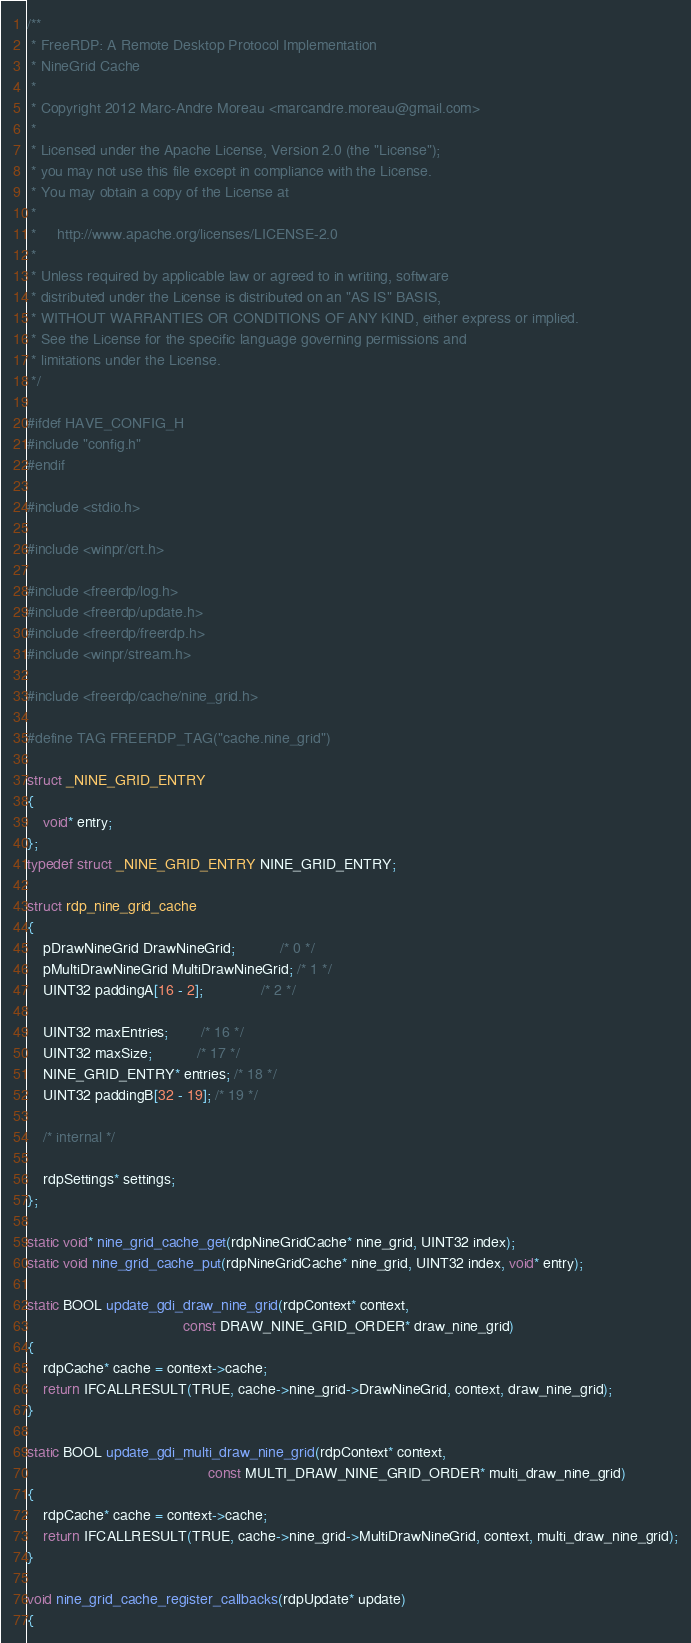Convert code to text. <code><loc_0><loc_0><loc_500><loc_500><_C_>/**
 * FreeRDP: A Remote Desktop Protocol Implementation
 * NineGrid Cache
 *
 * Copyright 2012 Marc-Andre Moreau <marcandre.moreau@gmail.com>
 *
 * Licensed under the Apache License, Version 2.0 (the "License");
 * you may not use this file except in compliance with the License.
 * You may obtain a copy of the License at
 *
 *     http://www.apache.org/licenses/LICENSE-2.0
 *
 * Unless required by applicable law or agreed to in writing, software
 * distributed under the License is distributed on an "AS IS" BASIS,
 * WITHOUT WARRANTIES OR CONDITIONS OF ANY KIND, either express or implied.
 * See the License for the specific language governing permissions and
 * limitations under the License.
 */

#ifdef HAVE_CONFIG_H
#include "config.h"
#endif

#include <stdio.h>

#include <winpr/crt.h>

#include <freerdp/log.h>
#include <freerdp/update.h>
#include <freerdp/freerdp.h>
#include <winpr/stream.h>

#include <freerdp/cache/nine_grid.h>

#define TAG FREERDP_TAG("cache.nine_grid")

struct _NINE_GRID_ENTRY
{
	void* entry;
};
typedef struct _NINE_GRID_ENTRY NINE_GRID_ENTRY;

struct rdp_nine_grid_cache
{
	pDrawNineGrid DrawNineGrid;           /* 0 */
	pMultiDrawNineGrid MultiDrawNineGrid; /* 1 */
	UINT32 paddingA[16 - 2];              /* 2 */

	UINT32 maxEntries;        /* 16 */
	UINT32 maxSize;           /* 17 */
	NINE_GRID_ENTRY* entries; /* 18 */
	UINT32 paddingB[32 - 19]; /* 19 */

	/* internal */

	rdpSettings* settings;
};

static void* nine_grid_cache_get(rdpNineGridCache* nine_grid, UINT32 index);
static void nine_grid_cache_put(rdpNineGridCache* nine_grid, UINT32 index, void* entry);

static BOOL update_gdi_draw_nine_grid(rdpContext* context,
                                      const DRAW_NINE_GRID_ORDER* draw_nine_grid)
{
	rdpCache* cache = context->cache;
	return IFCALLRESULT(TRUE, cache->nine_grid->DrawNineGrid, context, draw_nine_grid);
}

static BOOL update_gdi_multi_draw_nine_grid(rdpContext* context,
                                            const MULTI_DRAW_NINE_GRID_ORDER* multi_draw_nine_grid)
{
	rdpCache* cache = context->cache;
	return IFCALLRESULT(TRUE, cache->nine_grid->MultiDrawNineGrid, context, multi_draw_nine_grid);
}

void nine_grid_cache_register_callbacks(rdpUpdate* update)
{</code> 